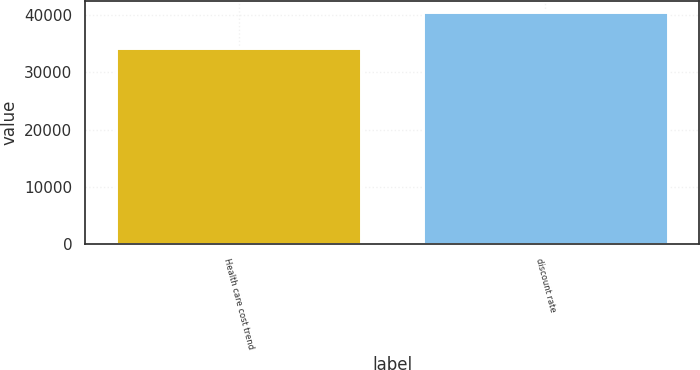<chart> <loc_0><loc_0><loc_500><loc_500><bar_chart><fcel>Health care cost trend<fcel>discount rate<nl><fcel>34291<fcel>40557<nl></chart> 